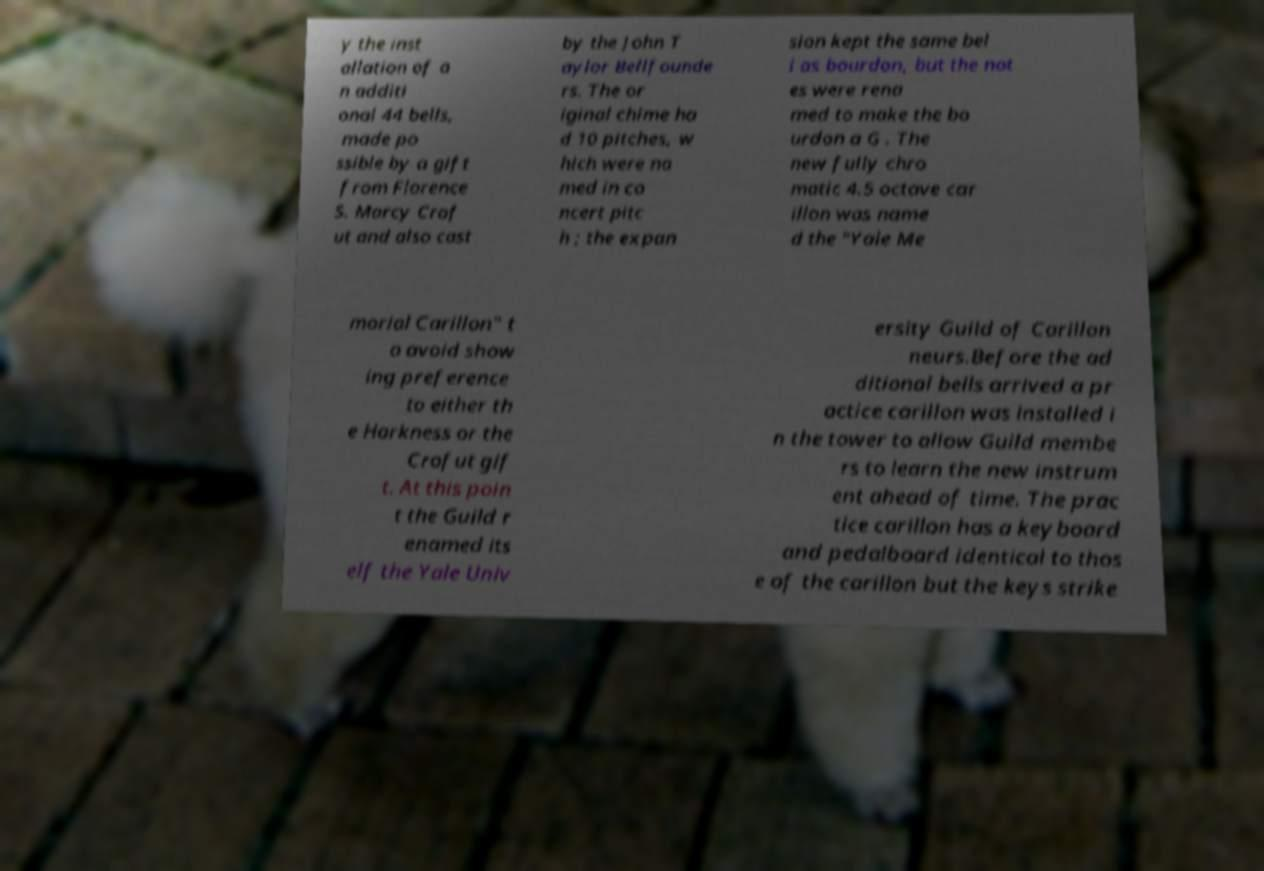Could you assist in decoding the text presented in this image and type it out clearly? y the inst allation of a n additi onal 44 bells, made po ssible by a gift from Florence S. Marcy Crof ut and also cast by the John T aylor Bellfounde rs. The or iginal chime ha d 10 pitches, w hich were na med in co ncert pitc h ; the expan sion kept the same bel l as bourdon, but the not es were rena med to make the bo urdon a G . The new fully chro matic 4.5 octave car illon was name d the "Yale Me morial Carillon" t o avoid show ing preference to either th e Harkness or the Crofut gif t. At this poin t the Guild r enamed its elf the Yale Univ ersity Guild of Carillon neurs.Before the ad ditional bells arrived a pr actice carillon was installed i n the tower to allow Guild membe rs to learn the new instrum ent ahead of time. The prac tice carillon has a keyboard and pedalboard identical to thos e of the carillon but the keys strike 